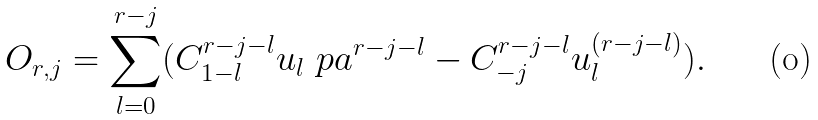Convert formula to latex. <formula><loc_0><loc_0><loc_500><loc_500>O _ { r , j } = \sum _ { l = 0 } ^ { r - j } ( C _ { 1 - l } ^ { r - j - l } u _ { l } \ p a ^ { r - j - l } - C _ { - j } ^ { r - j - l } u _ { l } ^ { ( r - j - l ) } ) .</formula> 